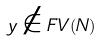Convert formula to latex. <formula><loc_0><loc_0><loc_500><loc_500>y \notin F V ( N )</formula> 